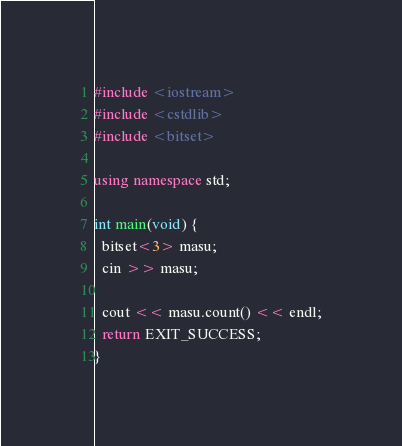<code> <loc_0><loc_0><loc_500><loc_500><_C++_>#include <iostream>
#include <cstdlib>
#include <bitset>

using namespace std;

int main(void) {
  bitset<3> masu;
  cin >> masu;

  cout << masu.count() << endl;
  return EXIT_SUCCESS;
}
</code> 